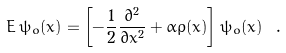<formula> <loc_0><loc_0><loc_500><loc_500>E \, \psi _ { o } ( x ) = \left [ - \frac { 1 } { 2 } \frac { \partial ^ { 2 } } { \partial x ^ { 2 } } + \alpha \rho ( x ) \right ] \psi _ { o } ( x ) \ .</formula> 